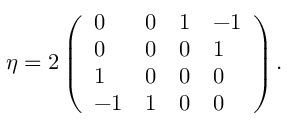<formula> <loc_0><loc_0><loc_500><loc_500>\eta = 2 \left ( \begin{array} { l l l l } { 0 } & { 0 } & { 1 } & { - 1 } \\ { 0 } & { 0 } & { 0 } & { 1 } \\ { 1 } & { 0 } & { 0 } & { 0 } \\ { - 1 } & { 1 } & { 0 } & { 0 } \end{array} \right ) .</formula> 